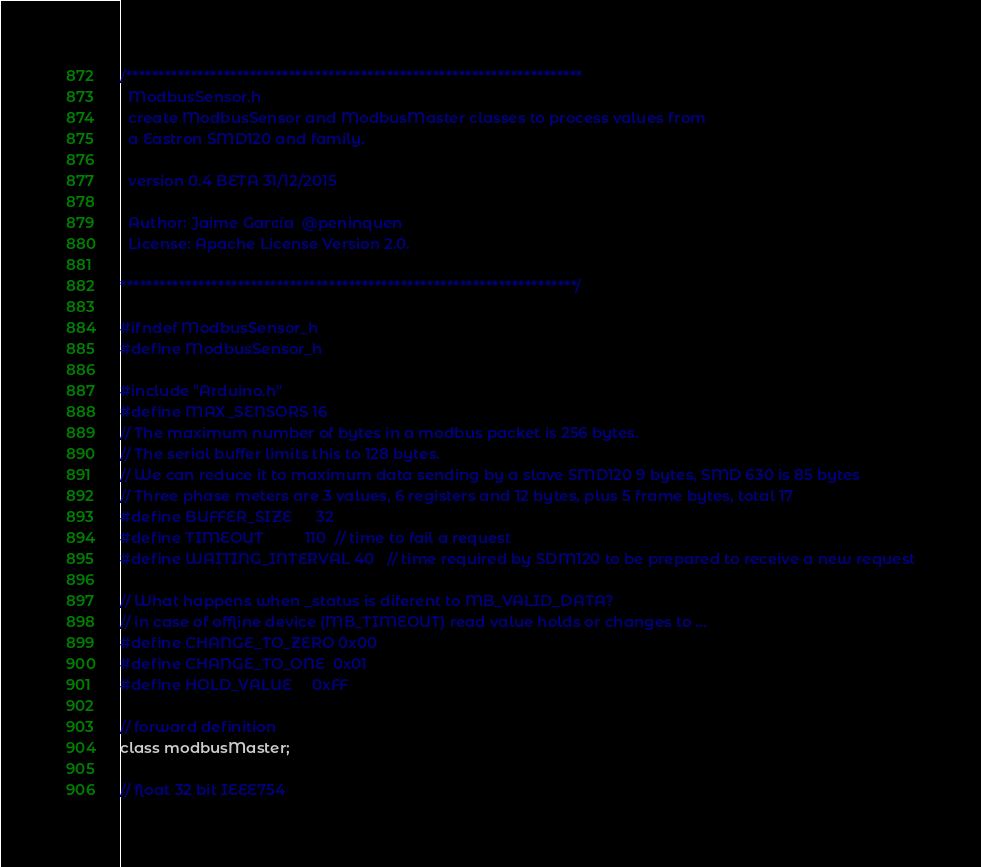Convert code to text. <code><loc_0><loc_0><loc_500><loc_500><_C_>/**********************************************************************
  ModbusSensor.h
  create ModbusSensor and ModbusMaster classes to process values from
  a Eastron SMD120 and family.

  version 0.4 BETA 31/12/2015

  Author: Jaime García  @peninquen
  License: Apache License Version 2.0.

**********************************************************************/

#ifndef ModbusSensor_h
#define ModbusSensor_h

#include "Arduino.h"
#define MAX_SENSORS 16
// The maximum number of bytes in a modbus packet is 256 bytes.
// The serial buffer limits this to 128 bytes.
// We can reduce it to maximum data sending by a slave SMD120 9 bytes, SMD 630 is 85 bytes
// Three phase meters are 3 values, 6 registers and 12 bytes, plus 5 frame bytes, total 17
#define BUFFER_SIZE      32
#define TIMEOUT          110  // time to fail a request 
#define WAITING_INTERVAL 40   // time required by SDM120 to be prepared to receive a new request

// What happens when _status is diferent to MB_VALID_DATA?
// in case of offline device (MB_TIMEOUT) read value holds or changes to ...
#define CHANGE_TO_ZERO 0x00
#define CHANGE_TO_ONE  0x01
#define HOLD_VALUE     0xFF

// forward definition
class modbusMaster;

// float 32 bit IEEE754</code> 